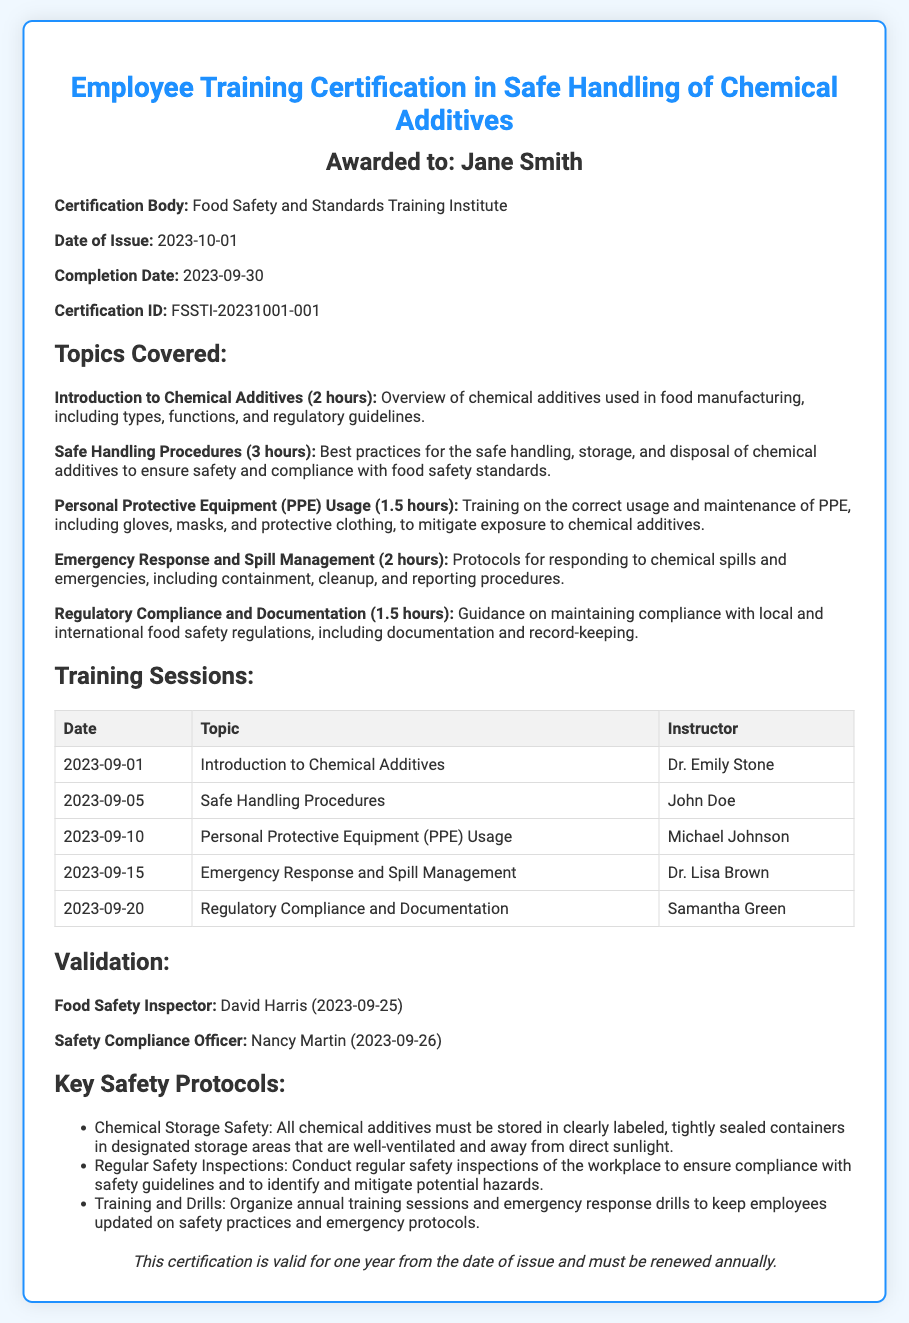What is the full name of the recipient? The recipient's name is stated at the top of the document in the header section.
Answer: Jane Smith Who issued the certification? The certification body is mentioned in the details section of the document.
Answer: Food Safety and Standards Training Institute When was the certification issued? The issue date is clearly stated in the details section of the document.
Answer: 2023-10-01 How many hours were allocated to "Safe Handling Procedures"? The duration for this topic is detailed in the topics covered section of the document.
Answer: 3 hours Who taught the "Emergency Response and Spill Management" session? The instructor's name for this session is provided in the training sessions table.
Answer: Dr. Lisa Brown What date did the validation by the Food Safety Inspector occur? This information is provided in the validations section of the document.
Answer: 2023-09-25 What is the certification ID? The certification ID is listed in the details section of the document.
Answer: FSSTI-20231001-001 What is the validity period of the certification? The validity of the certification is mentioned in the footer section of the document.
Answer: One year How many training topics were covered? The number of topics can be counted from the topics covered section of the document.
Answer: Five 